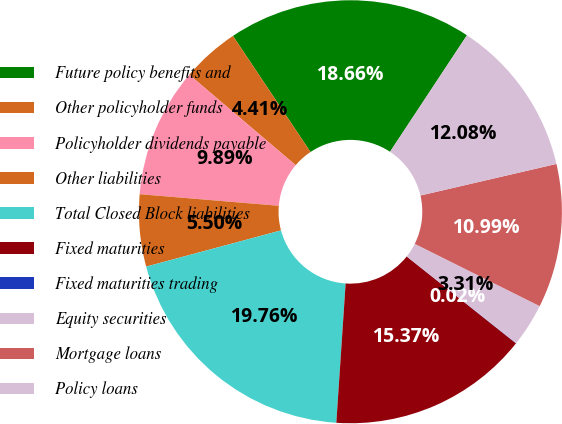Convert chart to OTSL. <chart><loc_0><loc_0><loc_500><loc_500><pie_chart><fcel>Future policy benefits and<fcel>Other policyholder funds<fcel>Policyholder dividends payable<fcel>Other liabilities<fcel>Total Closed Block liabilities<fcel>Fixed maturities<fcel>Fixed maturities trading<fcel>Equity securities<fcel>Mortgage loans<fcel>Policy loans<nl><fcel>18.66%<fcel>4.41%<fcel>9.89%<fcel>5.5%<fcel>19.76%<fcel>15.37%<fcel>0.02%<fcel>3.31%<fcel>10.99%<fcel>12.08%<nl></chart> 